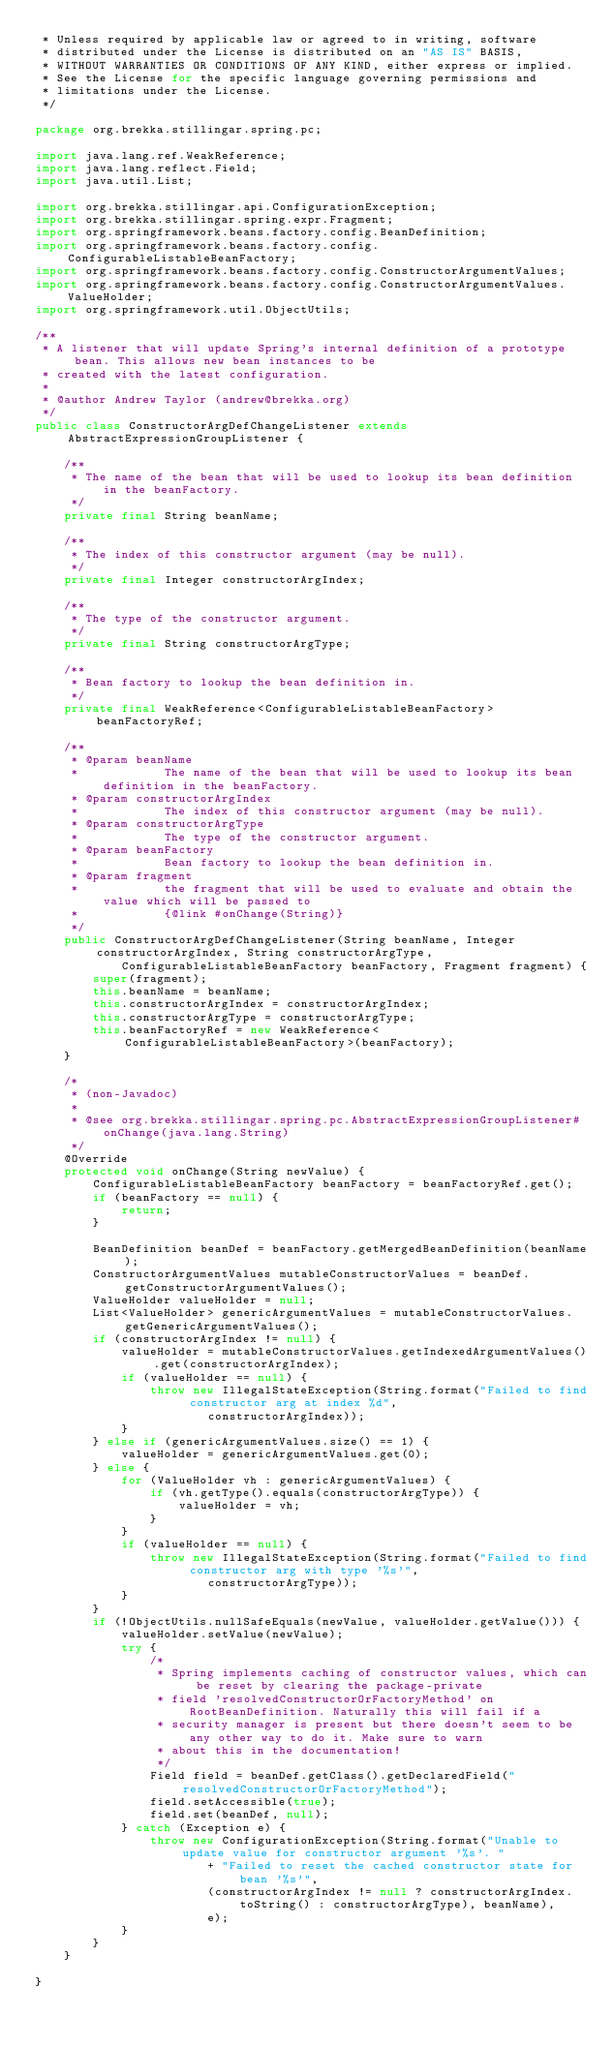<code> <loc_0><loc_0><loc_500><loc_500><_Java_> * Unless required by applicable law or agreed to in writing, software
 * distributed under the License is distributed on an "AS IS" BASIS,
 * WITHOUT WARRANTIES OR CONDITIONS OF ANY KIND, either express or implied.
 * See the License for the specific language governing permissions and
 * limitations under the License.
 */

package org.brekka.stillingar.spring.pc;

import java.lang.ref.WeakReference;
import java.lang.reflect.Field;
import java.util.List;

import org.brekka.stillingar.api.ConfigurationException;
import org.brekka.stillingar.spring.expr.Fragment;
import org.springframework.beans.factory.config.BeanDefinition;
import org.springframework.beans.factory.config.ConfigurableListableBeanFactory;
import org.springframework.beans.factory.config.ConstructorArgumentValues;
import org.springframework.beans.factory.config.ConstructorArgumentValues.ValueHolder;
import org.springframework.util.ObjectUtils;

/**
 * A listener that will update Spring's internal definition of a prototype bean. This allows new bean instances to be
 * created with the latest configuration.
 * 
 * @author Andrew Taylor (andrew@brekka.org)
 */
public class ConstructorArgDefChangeListener extends AbstractExpressionGroupListener {

    /**
     * The name of the bean that will be used to lookup its bean definition in the beanFactory.
     */
    private final String beanName;

    /**
     * The index of this constructor argument (may be null).
     */
    private final Integer constructorArgIndex;

    /**
     * The type of the constructor argument.
     */
    private final String constructorArgType;

    /**
     * Bean factory to lookup the bean definition in.
     */
    private final WeakReference<ConfigurableListableBeanFactory> beanFactoryRef;

    /**
     * @param beanName
     *            The name of the bean that will be used to lookup its bean definition in the beanFactory.
     * @param constructorArgIndex
     *            The index of this constructor argument (may be null).
     * @param constructorArgType
     *            The type of the constructor argument.
     * @param beanFactory
     *            Bean factory to lookup the bean definition in.
     * @param fragment
     *            the fragment that will be used to evaluate and obtain the value which will be passed to
     *            {@link #onChange(String)}
     */
    public ConstructorArgDefChangeListener(String beanName, Integer constructorArgIndex, String constructorArgType,
            ConfigurableListableBeanFactory beanFactory, Fragment fragment) {
        super(fragment);
        this.beanName = beanName;
        this.constructorArgIndex = constructorArgIndex;
        this.constructorArgType = constructorArgType;
        this.beanFactoryRef = new WeakReference<ConfigurableListableBeanFactory>(beanFactory);
    }

    /*
     * (non-Javadoc)
     * 
     * @see org.brekka.stillingar.spring.pc.AbstractExpressionGroupListener#onChange(java.lang.String)
     */
    @Override
    protected void onChange(String newValue) {
        ConfigurableListableBeanFactory beanFactory = beanFactoryRef.get();
        if (beanFactory == null) {
            return;
        }
        
        BeanDefinition beanDef = beanFactory.getMergedBeanDefinition(beanName);
        ConstructorArgumentValues mutableConstructorValues = beanDef.getConstructorArgumentValues();
        ValueHolder valueHolder = null;
        List<ValueHolder> genericArgumentValues = mutableConstructorValues.getGenericArgumentValues();
        if (constructorArgIndex != null) {
            valueHolder = mutableConstructorValues.getIndexedArgumentValues().get(constructorArgIndex);
            if (valueHolder == null) {
                throw new IllegalStateException(String.format("Failed to find constructor arg at index %d",
                        constructorArgIndex));
            }
        } else if (genericArgumentValues.size() == 1) {
            valueHolder = genericArgumentValues.get(0);
        } else {
            for (ValueHolder vh : genericArgumentValues) {
                if (vh.getType().equals(constructorArgType)) {
                    valueHolder = vh;
                }
            }
            if (valueHolder == null) {
                throw new IllegalStateException(String.format("Failed to find constructor arg with type '%s'",
                        constructorArgType));
            }
        }
        if (!ObjectUtils.nullSafeEquals(newValue, valueHolder.getValue())) {
            valueHolder.setValue(newValue);
            try {
                /*
                 * Spring implements caching of constructor values, which can be reset by clearing the package-private
                 * field 'resolvedConstructorOrFactoryMethod' on RootBeanDefinition. Naturally this will fail if a
                 * security manager is present but there doesn't seem to be any other way to do it. Make sure to warn
                 * about this in the documentation!
                 */
                Field field = beanDef.getClass().getDeclaredField("resolvedConstructorOrFactoryMethod");
                field.setAccessible(true);
                field.set(beanDef, null);
            } catch (Exception e) {
                throw new ConfigurationException(String.format("Unable to update value for constructor argument '%s'. "
                        + "Failed to reset the cached constructor state for bean '%s'",
                        (constructorArgIndex != null ? constructorArgIndex.toString() : constructorArgType), beanName),
                        e);
            }
        }
    }

}
</code> 